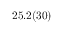Convert formula to latex. <formula><loc_0><loc_0><loc_500><loc_500>2 5 . 2 ( 3 0 )</formula> 